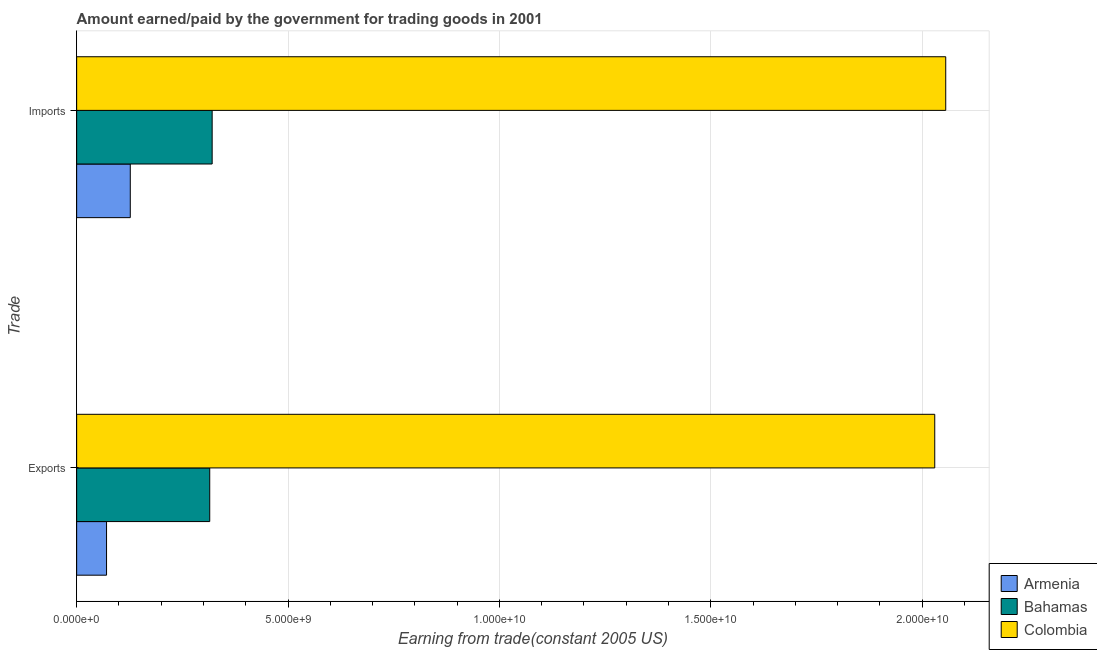How many different coloured bars are there?
Ensure brevity in your answer.  3. How many groups of bars are there?
Make the answer very short. 2. Are the number of bars per tick equal to the number of legend labels?
Provide a succinct answer. Yes. How many bars are there on the 1st tick from the top?
Provide a succinct answer. 3. What is the label of the 2nd group of bars from the top?
Provide a short and direct response. Exports. What is the amount earned from exports in Bahamas?
Offer a terse response. 3.15e+09. Across all countries, what is the maximum amount paid for imports?
Your response must be concise. 2.06e+1. Across all countries, what is the minimum amount earned from exports?
Your answer should be compact. 7.07e+08. In which country was the amount paid for imports minimum?
Keep it short and to the point. Armenia. What is the total amount paid for imports in the graph?
Your answer should be compact. 2.50e+1. What is the difference between the amount earned from exports in Colombia and that in Armenia?
Offer a very short reply. 1.96e+1. What is the difference between the amount paid for imports in Bahamas and the amount earned from exports in Colombia?
Keep it short and to the point. -1.71e+1. What is the average amount paid for imports per country?
Provide a short and direct response. 8.34e+09. What is the difference between the amount earned from exports and amount paid for imports in Bahamas?
Offer a very short reply. -5.75e+07. What is the ratio of the amount earned from exports in Armenia to that in Bahamas?
Your response must be concise. 0.22. In how many countries, is the amount paid for imports greater than the average amount paid for imports taken over all countries?
Your answer should be very brief. 1. What does the 2nd bar from the top in Exports represents?
Ensure brevity in your answer.  Bahamas. How many bars are there?
Keep it short and to the point. 6. Are all the bars in the graph horizontal?
Your answer should be very brief. Yes. What is the difference between two consecutive major ticks on the X-axis?
Your answer should be very brief. 5.00e+09. Are the values on the major ticks of X-axis written in scientific E-notation?
Give a very brief answer. Yes. Does the graph contain any zero values?
Your response must be concise. No. Does the graph contain grids?
Offer a very short reply. Yes. Where does the legend appear in the graph?
Your answer should be compact. Bottom right. How are the legend labels stacked?
Ensure brevity in your answer.  Vertical. What is the title of the graph?
Make the answer very short. Amount earned/paid by the government for trading goods in 2001. What is the label or title of the X-axis?
Your response must be concise. Earning from trade(constant 2005 US). What is the label or title of the Y-axis?
Ensure brevity in your answer.  Trade. What is the Earning from trade(constant 2005 US) of Armenia in Exports?
Ensure brevity in your answer.  7.07e+08. What is the Earning from trade(constant 2005 US) in Bahamas in Exports?
Your answer should be very brief. 3.15e+09. What is the Earning from trade(constant 2005 US) of Colombia in Exports?
Your answer should be compact. 2.03e+1. What is the Earning from trade(constant 2005 US) in Armenia in Imports?
Offer a terse response. 1.27e+09. What is the Earning from trade(constant 2005 US) of Bahamas in Imports?
Make the answer very short. 3.21e+09. What is the Earning from trade(constant 2005 US) in Colombia in Imports?
Make the answer very short. 2.06e+1. Across all Trade, what is the maximum Earning from trade(constant 2005 US) of Armenia?
Your response must be concise. 1.27e+09. Across all Trade, what is the maximum Earning from trade(constant 2005 US) in Bahamas?
Ensure brevity in your answer.  3.21e+09. Across all Trade, what is the maximum Earning from trade(constant 2005 US) in Colombia?
Give a very brief answer. 2.06e+1. Across all Trade, what is the minimum Earning from trade(constant 2005 US) of Armenia?
Your answer should be compact. 7.07e+08. Across all Trade, what is the minimum Earning from trade(constant 2005 US) of Bahamas?
Offer a terse response. 3.15e+09. Across all Trade, what is the minimum Earning from trade(constant 2005 US) of Colombia?
Your answer should be compact. 2.03e+1. What is the total Earning from trade(constant 2005 US) of Armenia in the graph?
Your response must be concise. 1.98e+09. What is the total Earning from trade(constant 2005 US) of Bahamas in the graph?
Ensure brevity in your answer.  6.35e+09. What is the total Earning from trade(constant 2005 US) of Colombia in the graph?
Your response must be concise. 4.09e+1. What is the difference between the Earning from trade(constant 2005 US) in Armenia in Exports and that in Imports?
Your answer should be very brief. -5.62e+08. What is the difference between the Earning from trade(constant 2005 US) in Bahamas in Exports and that in Imports?
Offer a very short reply. -5.75e+07. What is the difference between the Earning from trade(constant 2005 US) in Colombia in Exports and that in Imports?
Give a very brief answer. -2.60e+08. What is the difference between the Earning from trade(constant 2005 US) in Armenia in Exports and the Earning from trade(constant 2005 US) in Bahamas in Imports?
Offer a terse response. -2.50e+09. What is the difference between the Earning from trade(constant 2005 US) of Armenia in Exports and the Earning from trade(constant 2005 US) of Colombia in Imports?
Make the answer very short. -1.99e+1. What is the difference between the Earning from trade(constant 2005 US) in Bahamas in Exports and the Earning from trade(constant 2005 US) in Colombia in Imports?
Give a very brief answer. -1.74e+1. What is the average Earning from trade(constant 2005 US) of Armenia per Trade?
Give a very brief answer. 9.88e+08. What is the average Earning from trade(constant 2005 US) of Bahamas per Trade?
Give a very brief answer. 3.18e+09. What is the average Earning from trade(constant 2005 US) in Colombia per Trade?
Offer a terse response. 2.04e+1. What is the difference between the Earning from trade(constant 2005 US) of Armenia and Earning from trade(constant 2005 US) of Bahamas in Exports?
Make the answer very short. -2.44e+09. What is the difference between the Earning from trade(constant 2005 US) of Armenia and Earning from trade(constant 2005 US) of Colombia in Exports?
Keep it short and to the point. -1.96e+1. What is the difference between the Earning from trade(constant 2005 US) of Bahamas and Earning from trade(constant 2005 US) of Colombia in Exports?
Give a very brief answer. -1.72e+1. What is the difference between the Earning from trade(constant 2005 US) of Armenia and Earning from trade(constant 2005 US) of Bahamas in Imports?
Offer a very short reply. -1.94e+09. What is the difference between the Earning from trade(constant 2005 US) of Armenia and Earning from trade(constant 2005 US) of Colombia in Imports?
Your answer should be very brief. -1.93e+1. What is the difference between the Earning from trade(constant 2005 US) of Bahamas and Earning from trade(constant 2005 US) of Colombia in Imports?
Offer a very short reply. -1.74e+1. What is the ratio of the Earning from trade(constant 2005 US) in Armenia in Exports to that in Imports?
Offer a terse response. 0.56. What is the ratio of the Earning from trade(constant 2005 US) in Bahamas in Exports to that in Imports?
Your answer should be very brief. 0.98. What is the ratio of the Earning from trade(constant 2005 US) in Colombia in Exports to that in Imports?
Provide a succinct answer. 0.99. What is the difference between the highest and the second highest Earning from trade(constant 2005 US) of Armenia?
Offer a terse response. 5.62e+08. What is the difference between the highest and the second highest Earning from trade(constant 2005 US) in Bahamas?
Your response must be concise. 5.75e+07. What is the difference between the highest and the second highest Earning from trade(constant 2005 US) in Colombia?
Your answer should be compact. 2.60e+08. What is the difference between the highest and the lowest Earning from trade(constant 2005 US) in Armenia?
Offer a terse response. 5.62e+08. What is the difference between the highest and the lowest Earning from trade(constant 2005 US) in Bahamas?
Offer a very short reply. 5.75e+07. What is the difference between the highest and the lowest Earning from trade(constant 2005 US) of Colombia?
Your response must be concise. 2.60e+08. 